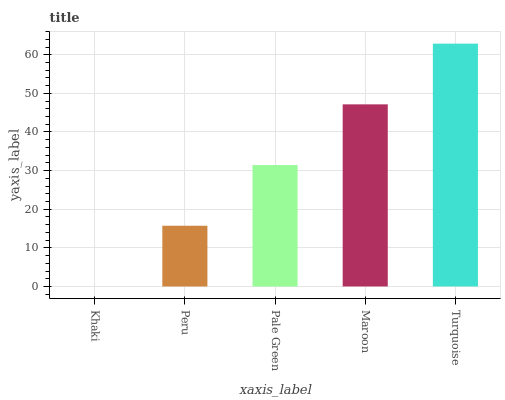Is Peru the minimum?
Answer yes or no. No. Is Peru the maximum?
Answer yes or no. No. Is Peru greater than Khaki?
Answer yes or no. Yes. Is Khaki less than Peru?
Answer yes or no. Yes. Is Khaki greater than Peru?
Answer yes or no. No. Is Peru less than Khaki?
Answer yes or no. No. Is Pale Green the high median?
Answer yes or no. Yes. Is Pale Green the low median?
Answer yes or no. Yes. Is Peru the high median?
Answer yes or no. No. Is Maroon the low median?
Answer yes or no. No. 